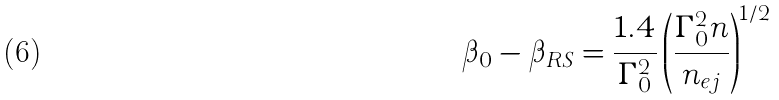<formula> <loc_0><loc_0><loc_500><loc_500>\beta _ { 0 } - \beta _ { R S } = \frac { 1 . 4 } { \Gamma _ { 0 } ^ { 2 } } \left ( \frac { \Gamma _ { 0 } ^ { 2 } n } { n _ { e j } } \right ) ^ { 1 / 2 }</formula> 